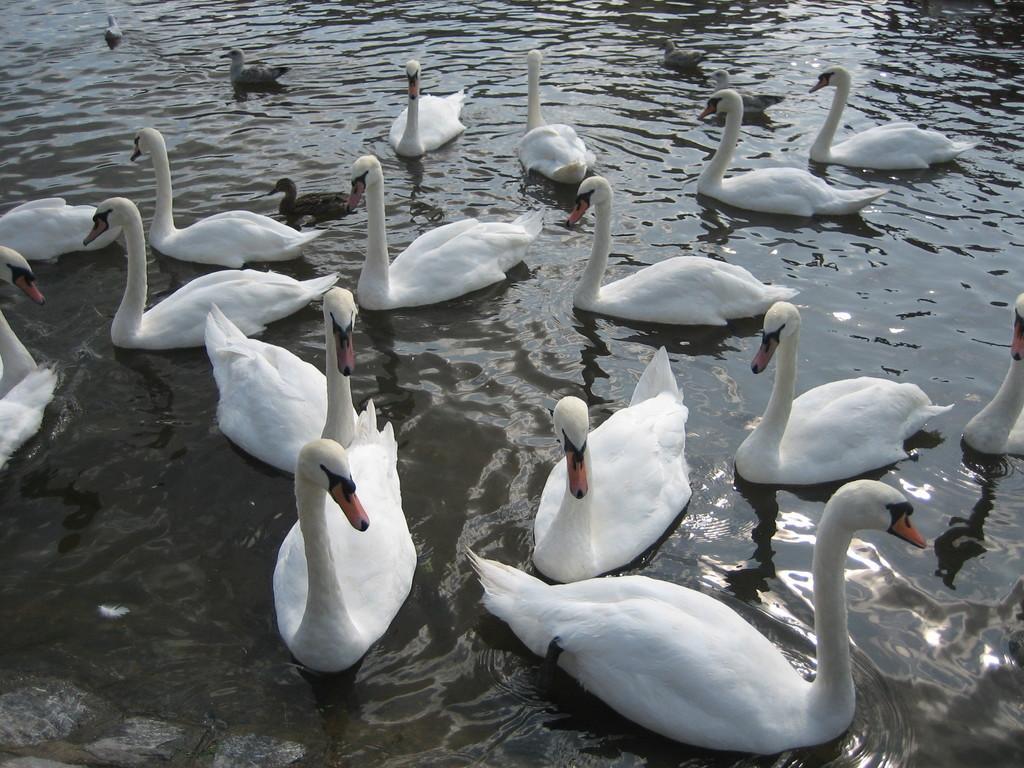How would you summarize this image in a sentence or two? These are the beautiful swans in white color swimming in the water, on the left side there are 2 birds in black color in the water. 